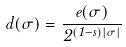Convert formula to latex. <formula><loc_0><loc_0><loc_500><loc_500>d ( \sigma ) = \frac { e ( \sigma ) } { 2 ^ { ( 1 - s ) | \sigma | } }</formula> 